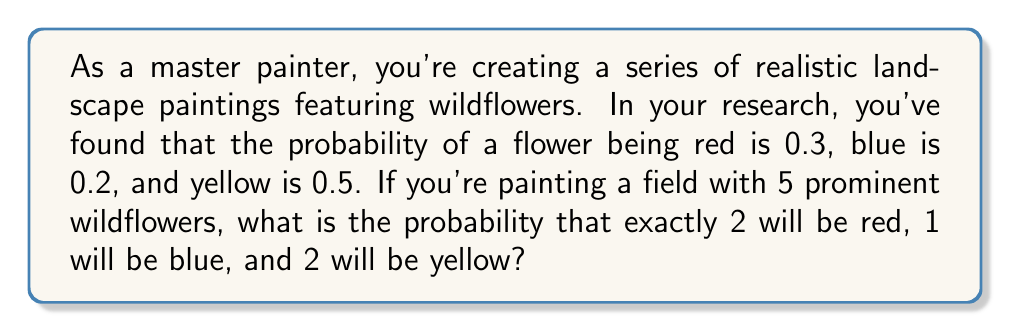Help me with this question. To solve this problem, we'll use the multinomial probability distribution, as we're dealing with multiple outcomes (colors) over multiple trials (flowers).

1. The probability mass function for the multinomial distribution is:

   $$P(X_1 = x_1, X_2 = x_2, ..., X_k = x_k) = \frac{n!}{x_1! x_2! ... x_k!} p_1^{x_1} p_2^{x_2} ... p_k^{x_k}$$

   Where:
   - $n$ is the total number of trials (flowers)
   - $x_i$ is the number of occurrences of each outcome
   - $p_i$ is the probability of each outcome

2. In this case:
   - $n = 5$ (total flowers)
   - $x_1 = 2$ (red flowers), $x_2 = 1$ (blue flower), $x_3 = 2$ (yellow flowers)
   - $p_1 = 0.3$ (probability of red), $p_2 = 0.2$ (probability of blue), $p_3 = 0.5$ (probability of yellow)

3. Let's substitute these values into the formula:

   $$P(X_1 = 2, X_2 = 1, X_3 = 2) = \frac{5!}{2! 1! 2!} (0.3)^2 (0.2)^1 (0.5)^2$$

4. Simplify:
   $$= \frac{5 \cdot 4 \cdot 3 \cdot 2 \cdot 1}{(2 \cdot 1)(1)(2 \cdot 1)} \cdot 0.09 \cdot 0.2 \cdot 0.25$$
   $$= \frac{120}{4} \cdot 0.0045$$
   $$= 30 \cdot 0.0045$$
   $$= 0.135$$

Thus, the probability of exactly 2 red, 1 blue, and 2 yellow flowers in a field of 5 flowers is 0.135 or 13.5%.
Answer: 0.135 